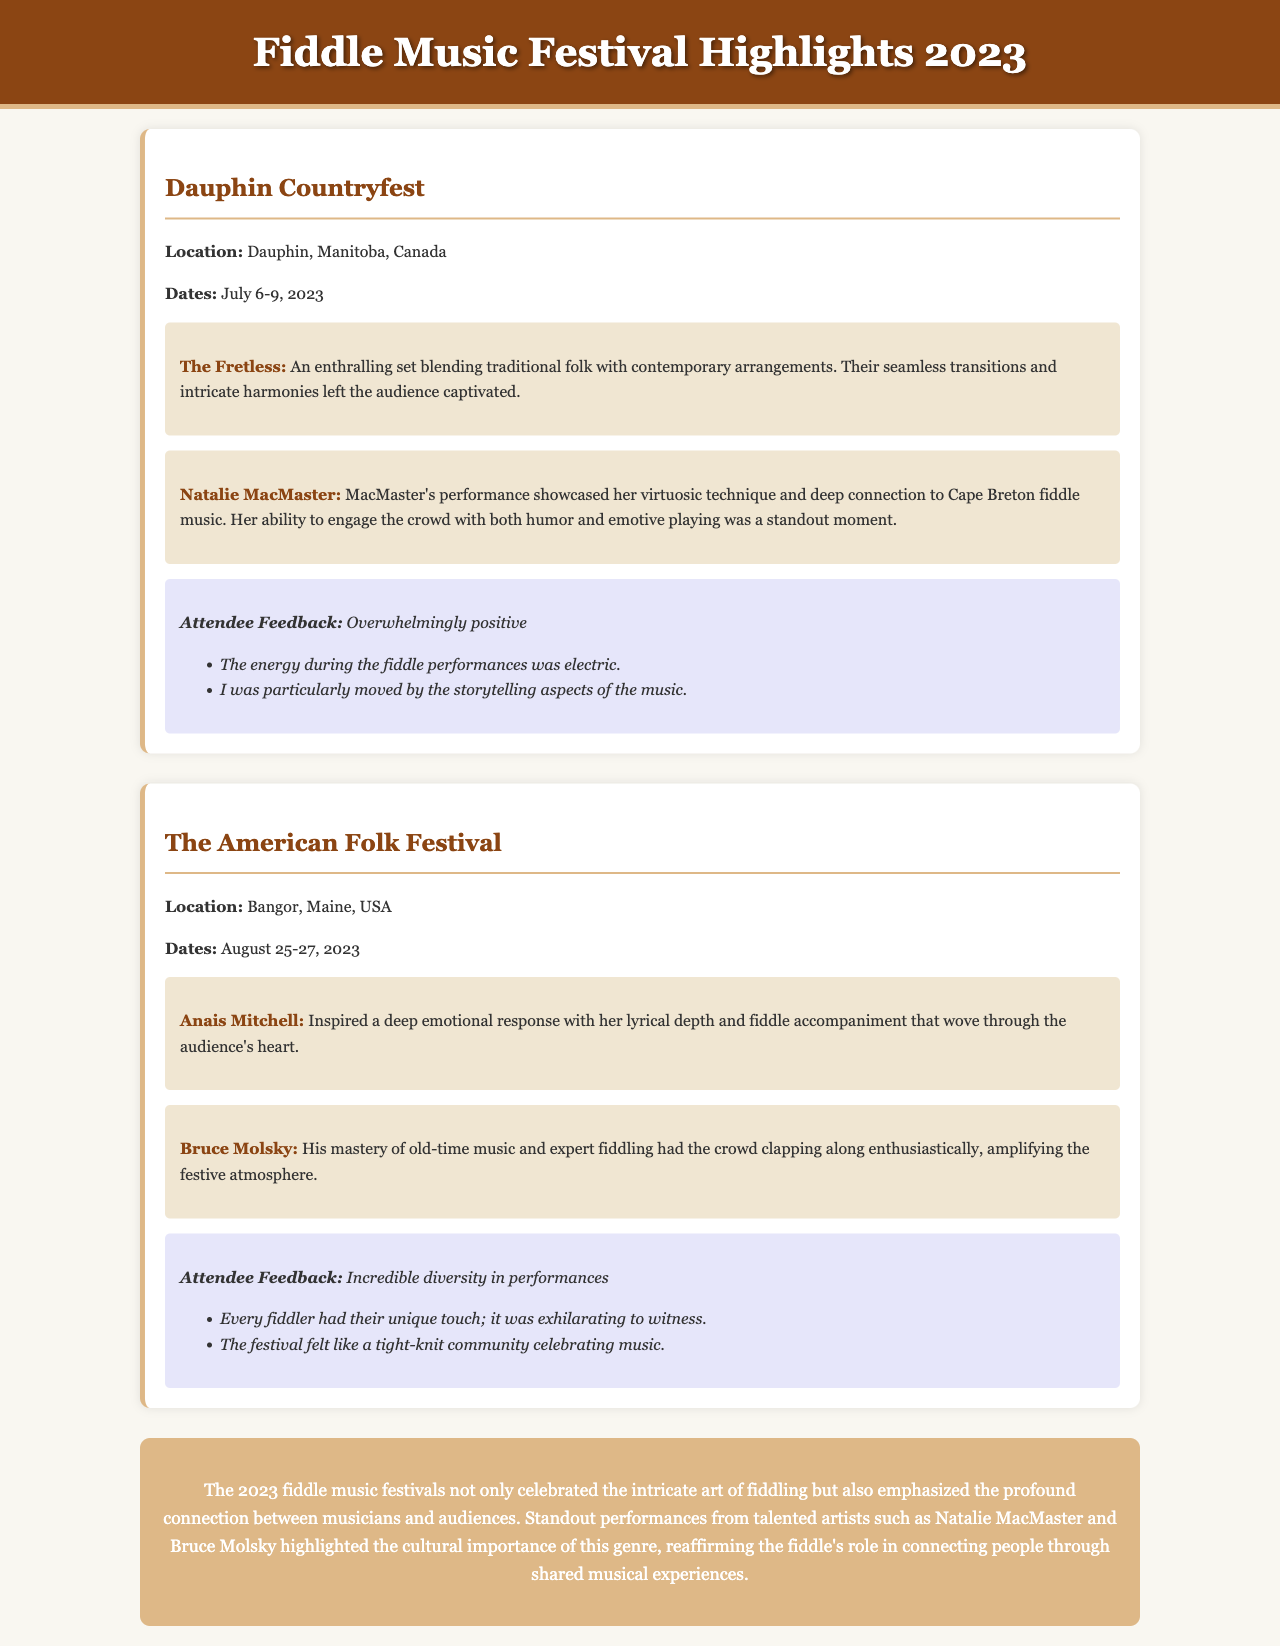What is the location of Dauphin Countryfest? The location is mentioned in the document as Dauphin, Manitoba, Canada.
Answer: Dauphin, Manitoba, Canada What are the dates for The American Folk Festival? The dates are clearly stated in the document as August 25-27, 2023.
Answer: August 25-27, 2023 Who performed an enthralling set at Dauphin Countryfest? The document highlights "The Fretless" as a performer with an enthralling set.
Answer: The Fretless Which artist showcased a deep connection to Cape Breton fiddle music? Natalie MacMaster is identified in the document as showcasing this deep connection.
Answer: Natalie MacMaster What was the overall attendee feedback for The American Folk Festival? The document states that the feedback was incredible diversity in performances.
Answer: Incredible diversity in performances How did Bruce Molsky engage the crowd during his performance? The document notes that Bruce Molsky engaged the crowd by having them clap along enthusiastically.
Answer: Clapping along enthusiastically What was a standout moment from Natalie MacMaster's performance? The document mentions her ability to engage the crowd with both humor and emotive playing as a standout moment.
Answer: Humor and emotive playing What is the common theme emphasized in the 2023 fiddle music festivals? The conclusion of the document emphasizes the profound connection between musicians and audiences.
Answer: Profound connection between musicians and audiences 